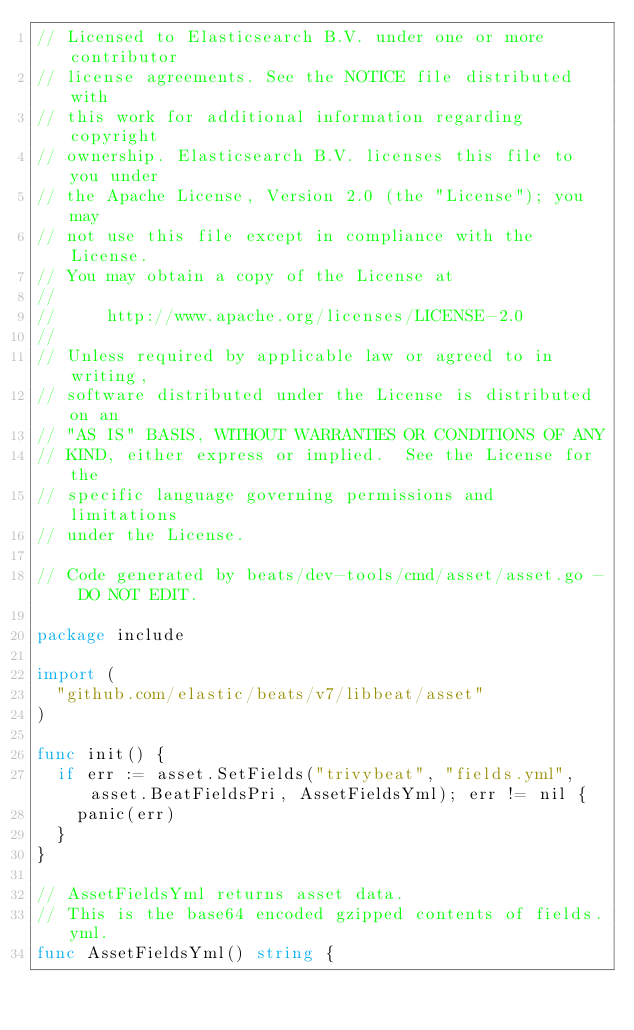<code> <loc_0><loc_0><loc_500><loc_500><_Go_>// Licensed to Elasticsearch B.V. under one or more contributor
// license agreements. See the NOTICE file distributed with
// this work for additional information regarding copyright
// ownership. Elasticsearch B.V. licenses this file to you under
// the Apache License, Version 2.0 (the "License"); you may
// not use this file except in compliance with the License.
// You may obtain a copy of the License at
//
//     http://www.apache.org/licenses/LICENSE-2.0
//
// Unless required by applicable law or agreed to in writing,
// software distributed under the License is distributed on an
// "AS IS" BASIS, WITHOUT WARRANTIES OR CONDITIONS OF ANY
// KIND, either express or implied.  See the License for the
// specific language governing permissions and limitations
// under the License.

// Code generated by beats/dev-tools/cmd/asset/asset.go - DO NOT EDIT.

package include

import (
	"github.com/elastic/beats/v7/libbeat/asset"
)

func init() {
	if err := asset.SetFields("trivybeat", "fields.yml", asset.BeatFieldsPri, AssetFieldsYml); err != nil {
		panic(err)
	}
}

// AssetFieldsYml returns asset data.
// This is the base64 encoded gzipped contents of fields.yml.
func AssetFieldsYml() string {</code> 